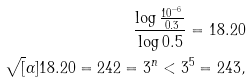<formula> <loc_0><loc_0><loc_500><loc_500>\frac { \log \frac { 1 0 ^ { - 6 } } { 0 . 3 } } { \log 0 . 5 } = 1 8 . 2 0 \\ \sqrt { [ } \alpha ] { 1 8 . 2 0 } = 2 4 2 = 3 ^ { n } < 3 ^ { 5 } = 2 4 3 ,</formula> 